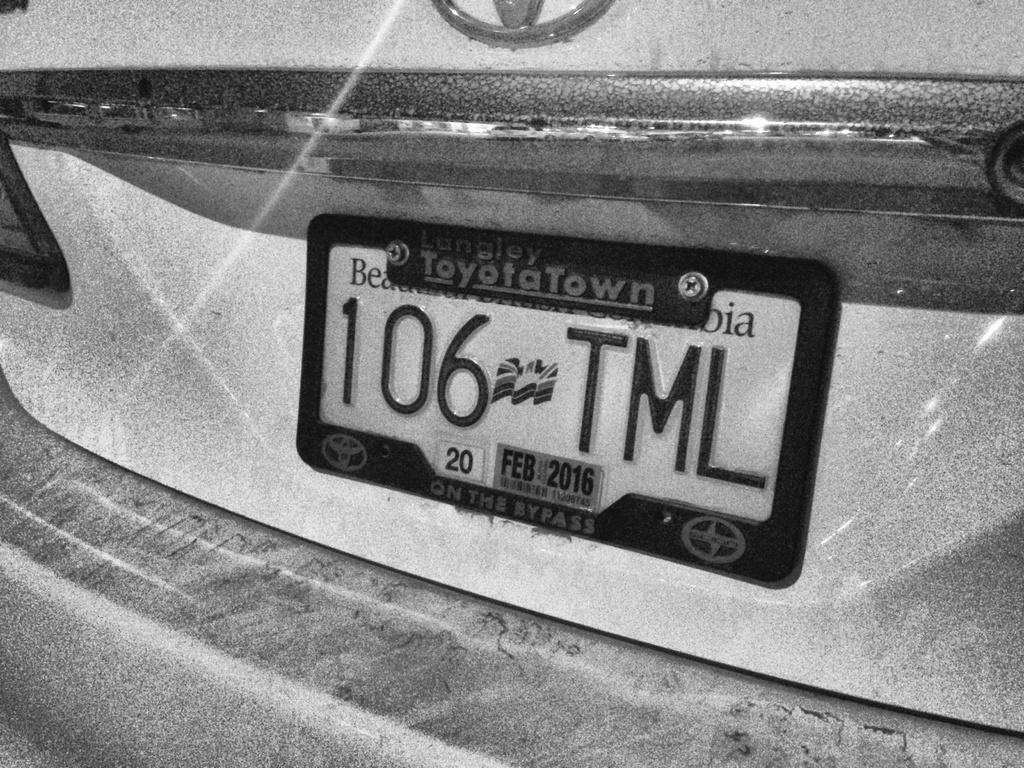What is the color scheme of the image? The image is black and white. What can be seen in the image related to a motor vehicle? There is a name plate of a motor vehicle in the image. What type of animal can be seen in the image? There is no animal present in the image; it features a name plate of a motor vehicle. Can you tell me which hospital is depicted in the image? There is no hospital present in the image; it features a name plate of a motor vehicle. 